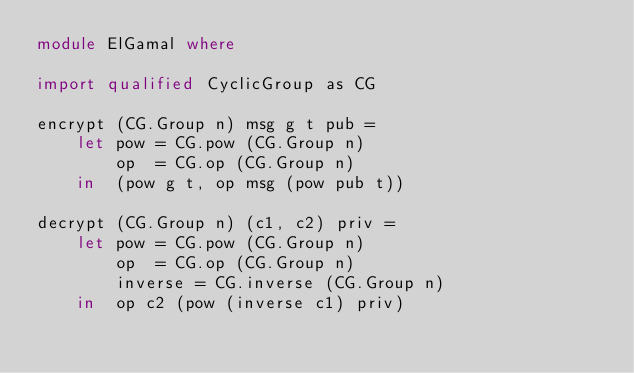<code> <loc_0><loc_0><loc_500><loc_500><_Haskell_>module ElGamal where

import qualified CyclicGroup as CG

encrypt (CG.Group n) msg g t pub = 
    let pow = CG.pow (CG.Group n)
        op  = CG.op (CG.Group n)
    in  (pow g t, op msg (pow pub t))

decrypt (CG.Group n) (c1, c2) priv =
    let pow = CG.pow (CG.Group n)
        op  = CG.op (CG.Group n)
        inverse = CG.inverse (CG.Group n)
    in  op c2 (pow (inverse c1) priv)

</code> 